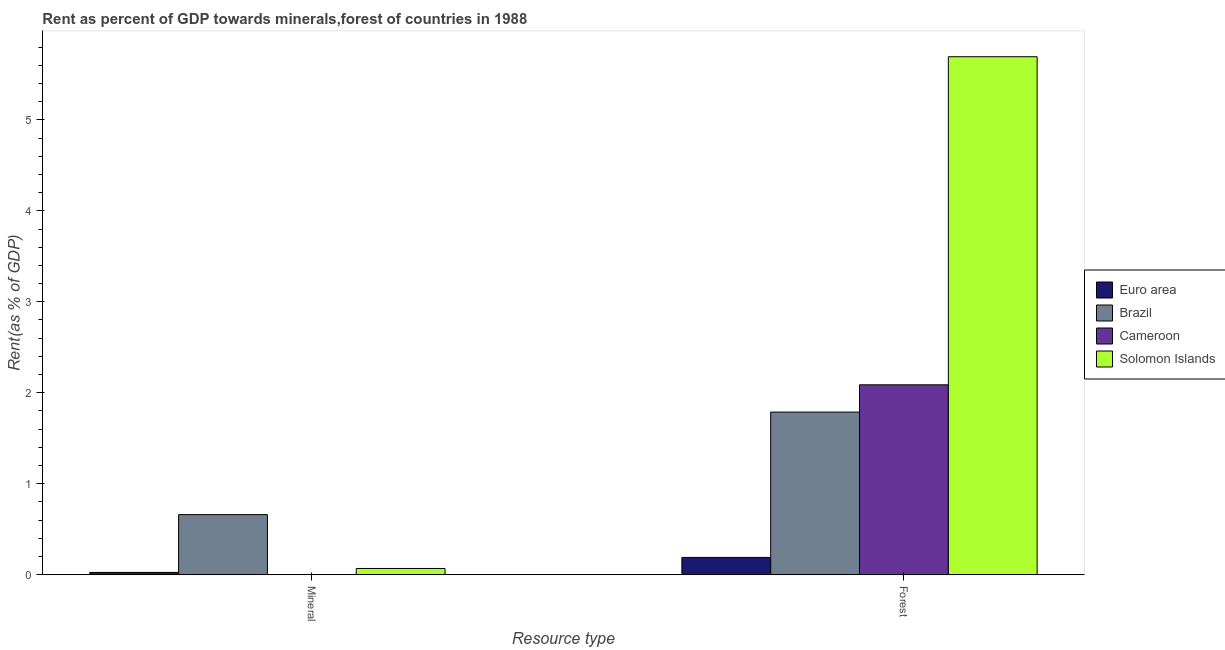How many groups of bars are there?
Make the answer very short. 2. Are the number of bars on each tick of the X-axis equal?
Offer a very short reply. Yes. How many bars are there on the 2nd tick from the left?
Your answer should be compact. 4. How many bars are there on the 2nd tick from the right?
Provide a succinct answer. 4. What is the label of the 2nd group of bars from the left?
Provide a succinct answer. Forest. What is the forest rent in Brazil?
Ensure brevity in your answer.  1.79. Across all countries, what is the maximum forest rent?
Provide a short and direct response. 5.69. Across all countries, what is the minimum mineral rent?
Give a very brief answer. 0. In which country was the mineral rent minimum?
Your answer should be compact. Cameroon. What is the total forest rent in the graph?
Offer a terse response. 9.76. What is the difference between the forest rent in Solomon Islands and that in Cameroon?
Give a very brief answer. 3.61. What is the difference between the forest rent in Cameroon and the mineral rent in Euro area?
Keep it short and to the point. 2.06. What is the average mineral rent per country?
Your answer should be compact. 0.19. What is the difference between the mineral rent and forest rent in Cameroon?
Offer a very short reply. -2.09. In how many countries, is the forest rent greater than 2.2 %?
Your answer should be very brief. 1. What is the ratio of the forest rent in Euro area to that in Brazil?
Make the answer very short. 0.11. How many bars are there?
Provide a short and direct response. 8. How many countries are there in the graph?
Provide a short and direct response. 4. What is the difference between two consecutive major ticks on the Y-axis?
Offer a very short reply. 1. Are the values on the major ticks of Y-axis written in scientific E-notation?
Provide a succinct answer. No. Does the graph contain grids?
Keep it short and to the point. No. How many legend labels are there?
Make the answer very short. 4. What is the title of the graph?
Make the answer very short. Rent as percent of GDP towards minerals,forest of countries in 1988. Does "China" appear as one of the legend labels in the graph?
Ensure brevity in your answer.  No. What is the label or title of the X-axis?
Provide a succinct answer. Resource type. What is the label or title of the Y-axis?
Ensure brevity in your answer.  Rent(as % of GDP). What is the Rent(as % of GDP) in Euro area in Mineral?
Provide a short and direct response. 0.03. What is the Rent(as % of GDP) of Brazil in Mineral?
Your answer should be very brief. 0.66. What is the Rent(as % of GDP) in Cameroon in Mineral?
Provide a short and direct response. 0. What is the Rent(as % of GDP) of Solomon Islands in Mineral?
Keep it short and to the point. 0.07. What is the Rent(as % of GDP) of Euro area in Forest?
Give a very brief answer. 0.19. What is the Rent(as % of GDP) in Brazil in Forest?
Provide a short and direct response. 1.79. What is the Rent(as % of GDP) of Cameroon in Forest?
Your answer should be very brief. 2.09. What is the Rent(as % of GDP) of Solomon Islands in Forest?
Your answer should be very brief. 5.69. Across all Resource type, what is the maximum Rent(as % of GDP) of Euro area?
Offer a very short reply. 0.19. Across all Resource type, what is the maximum Rent(as % of GDP) in Brazil?
Your answer should be very brief. 1.79. Across all Resource type, what is the maximum Rent(as % of GDP) in Cameroon?
Your answer should be very brief. 2.09. Across all Resource type, what is the maximum Rent(as % of GDP) of Solomon Islands?
Provide a succinct answer. 5.69. Across all Resource type, what is the minimum Rent(as % of GDP) of Euro area?
Keep it short and to the point. 0.03. Across all Resource type, what is the minimum Rent(as % of GDP) in Brazil?
Keep it short and to the point. 0.66. Across all Resource type, what is the minimum Rent(as % of GDP) in Cameroon?
Your response must be concise. 0. Across all Resource type, what is the minimum Rent(as % of GDP) of Solomon Islands?
Your answer should be very brief. 0.07. What is the total Rent(as % of GDP) in Euro area in the graph?
Provide a short and direct response. 0.21. What is the total Rent(as % of GDP) of Brazil in the graph?
Your answer should be very brief. 2.45. What is the total Rent(as % of GDP) in Cameroon in the graph?
Provide a short and direct response. 2.09. What is the total Rent(as % of GDP) of Solomon Islands in the graph?
Ensure brevity in your answer.  5.76. What is the difference between the Rent(as % of GDP) of Euro area in Mineral and that in Forest?
Your answer should be compact. -0.16. What is the difference between the Rent(as % of GDP) of Brazil in Mineral and that in Forest?
Give a very brief answer. -1.13. What is the difference between the Rent(as % of GDP) in Cameroon in Mineral and that in Forest?
Your answer should be compact. -2.09. What is the difference between the Rent(as % of GDP) in Solomon Islands in Mineral and that in Forest?
Your response must be concise. -5.63. What is the difference between the Rent(as % of GDP) of Euro area in Mineral and the Rent(as % of GDP) of Brazil in Forest?
Your answer should be compact. -1.76. What is the difference between the Rent(as % of GDP) of Euro area in Mineral and the Rent(as % of GDP) of Cameroon in Forest?
Provide a short and direct response. -2.06. What is the difference between the Rent(as % of GDP) of Euro area in Mineral and the Rent(as % of GDP) of Solomon Islands in Forest?
Ensure brevity in your answer.  -5.67. What is the difference between the Rent(as % of GDP) of Brazil in Mineral and the Rent(as % of GDP) of Cameroon in Forest?
Your answer should be very brief. -1.43. What is the difference between the Rent(as % of GDP) of Brazil in Mineral and the Rent(as % of GDP) of Solomon Islands in Forest?
Offer a very short reply. -5.03. What is the difference between the Rent(as % of GDP) of Cameroon in Mineral and the Rent(as % of GDP) of Solomon Islands in Forest?
Provide a succinct answer. -5.69. What is the average Rent(as % of GDP) in Euro area per Resource type?
Ensure brevity in your answer.  0.11. What is the average Rent(as % of GDP) of Brazil per Resource type?
Your answer should be compact. 1.22. What is the average Rent(as % of GDP) of Cameroon per Resource type?
Your answer should be compact. 1.04. What is the average Rent(as % of GDP) in Solomon Islands per Resource type?
Make the answer very short. 2.88. What is the difference between the Rent(as % of GDP) in Euro area and Rent(as % of GDP) in Brazil in Mineral?
Give a very brief answer. -0.64. What is the difference between the Rent(as % of GDP) of Euro area and Rent(as % of GDP) of Cameroon in Mineral?
Offer a terse response. 0.02. What is the difference between the Rent(as % of GDP) in Euro area and Rent(as % of GDP) in Solomon Islands in Mineral?
Keep it short and to the point. -0.04. What is the difference between the Rent(as % of GDP) of Brazil and Rent(as % of GDP) of Cameroon in Mineral?
Give a very brief answer. 0.66. What is the difference between the Rent(as % of GDP) of Brazil and Rent(as % of GDP) of Solomon Islands in Mineral?
Ensure brevity in your answer.  0.59. What is the difference between the Rent(as % of GDP) of Cameroon and Rent(as % of GDP) of Solomon Islands in Mineral?
Your answer should be very brief. -0.07. What is the difference between the Rent(as % of GDP) in Euro area and Rent(as % of GDP) in Brazil in Forest?
Your answer should be very brief. -1.6. What is the difference between the Rent(as % of GDP) in Euro area and Rent(as % of GDP) in Cameroon in Forest?
Keep it short and to the point. -1.9. What is the difference between the Rent(as % of GDP) in Euro area and Rent(as % of GDP) in Solomon Islands in Forest?
Provide a succinct answer. -5.5. What is the difference between the Rent(as % of GDP) in Brazil and Rent(as % of GDP) in Cameroon in Forest?
Give a very brief answer. -0.3. What is the difference between the Rent(as % of GDP) of Brazil and Rent(as % of GDP) of Solomon Islands in Forest?
Provide a short and direct response. -3.91. What is the difference between the Rent(as % of GDP) in Cameroon and Rent(as % of GDP) in Solomon Islands in Forest?
Your response must be concise. -3.61. What is the ratio of the Rent(as % of GDP) of Euro area in Mineral to that in Forest?
Your response must be concise. 0.13. What is the ratio of the Rent(as % of GDP) of Brazil in Mineral to that in Forest?
Keep it short and to the point. 0.37. What is the ratio of the Rent(as % of GDP) in Solomon Islands in Mineral to that in Forest?
Ensure brevity in your answer.  0.01. What is the difference between the highest and the second highest Rent(as % of GDP) of Euro area?
Give a very brief answer. 0.16. What is the difference between the highest and the second highest Rent(as % of GDP) of Brazil?
Provide a succinct answer. 1.13. What is the difference between the highest and the second highest Rent(as % of GDP) of Cameroon?
Offer a very short reply. 2.09. What is the difference between the highest and the second highest Rent(as % of GDP) in Solomon Islands?
Offer a very short reply. 5.63. What is the difference between the highest and the lowest Rent(as % of GDP) in Euro area?
Keep it short and to the point. 0.16. What is the difference between the highest and the lowest Rent(as % of GDP) of Brazil?
Your response must be concise. 1.13. What is the difference between the highest and the lowest Rent(as % of GDP) of Cameroon?
Provide a succinct answer. 2.09. What is the difference between the highest and the lowest Rent(as % of GDP) in Solomon Islands?
Give a very brief answer. 5.63. 